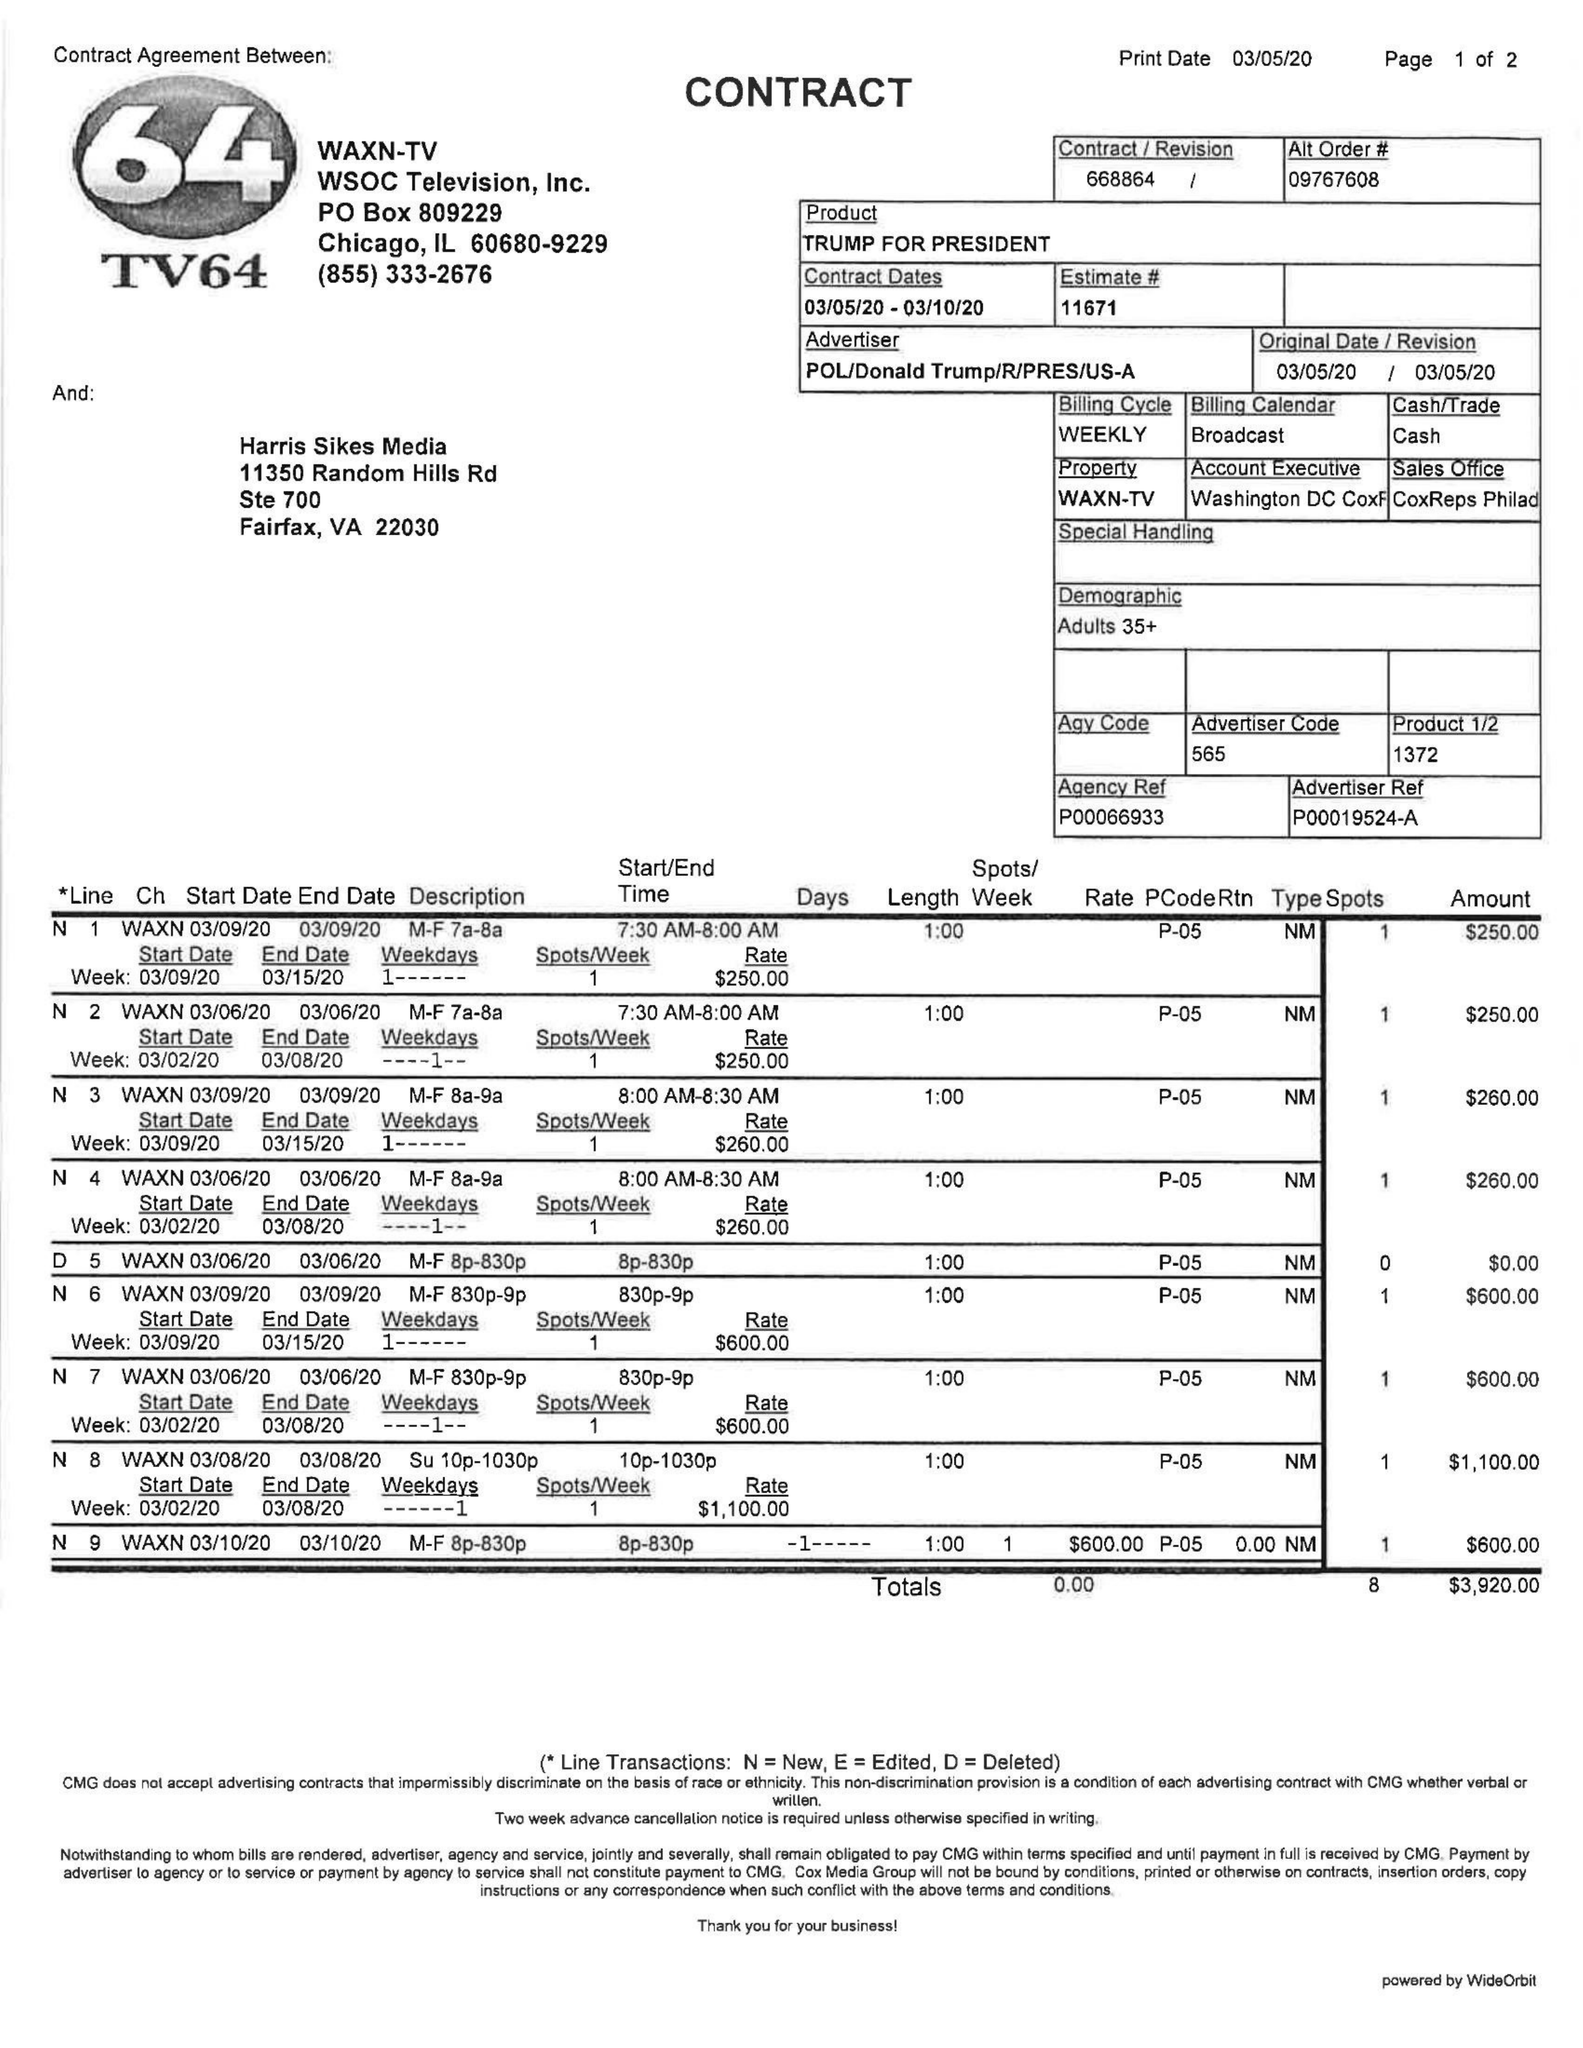What is the value for the flight_to?
Answer the question using a single word or phrase. 03/10/20 